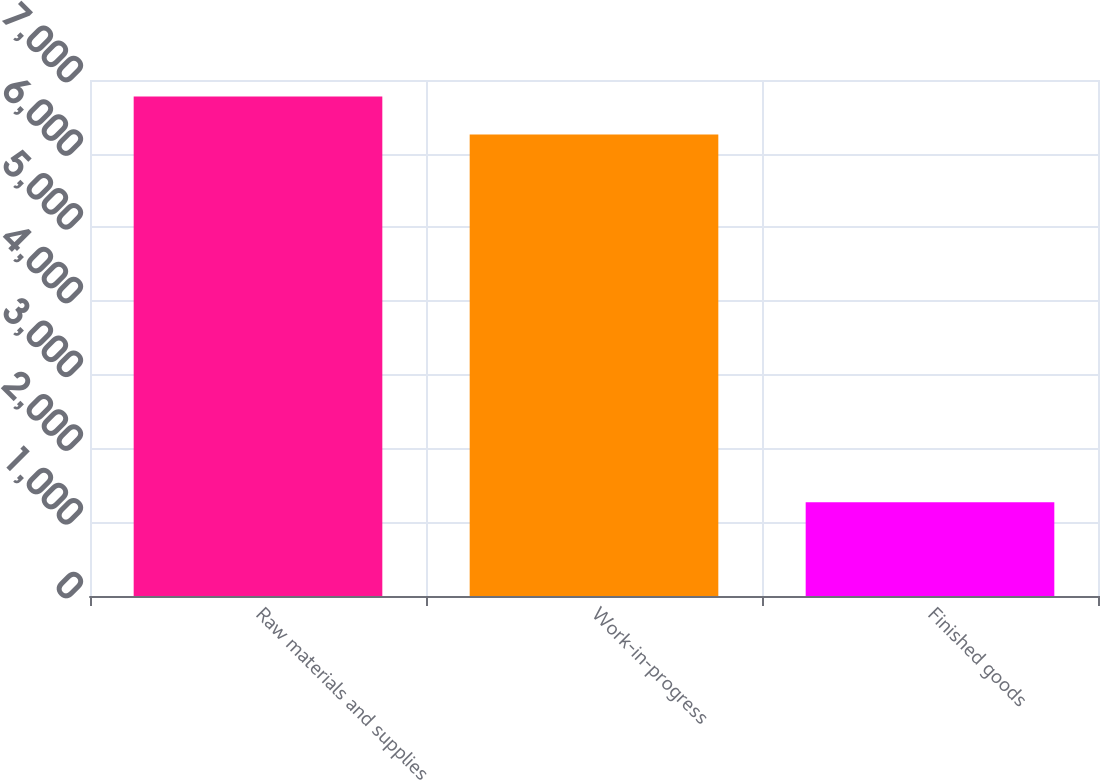Convert chart to OTSL. <chart><loc_0><loc_0><loc_500><loc_500><bar_chart><fcel>Raw materials and supplies<fcel>Work-in-progress<fcel>Finished goods<nl><fcel>6775.1<fcel>6261<fcel>1273<nl></chart> 